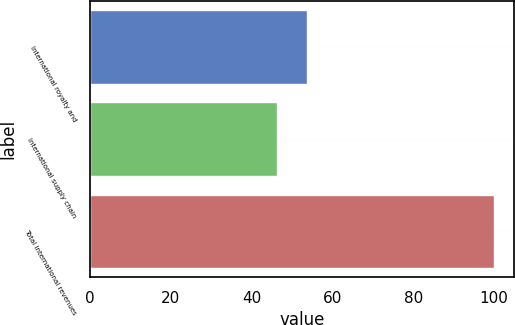Convert chart. <chart><loc_0><loc_0><loc_500><loc_500><bar_chart><fcel>International royalty and<fcel>International supply chain<fcel>Total international revenues<nl><fcel>53.7<fcel>46.3<fcel>100<nl></chart> 